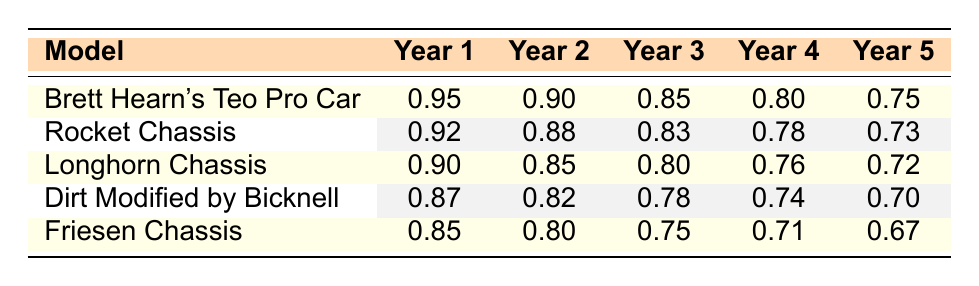What is the survival rate of Brett Hearn's Teo Pro Car after the first year? The survival rate for Brett Hearn's Teo Pro Car after the first year is listed directly in the table under "Year 1." It shows a survival rate of 0.95.
Answer: 0.95 Which car model has the highest survival rate after Year 3? Referring to the values in the "Year 3" column, Brett Hearn's Teo Pro Car has a survival rate of 0.85, Rocket Chassis has 0.83, Longhorn Chassis has 0.80, Dirt Modified by Bicknell has 0.78, and Friesen Chassis has 0.75. The highest among these is Brett Hearn's Teo Pro Car at 0.85.
Answer: Brett Hearn's Teo Pro Car What is the average survival rate for Year 2 across all car models? The "Year 2" survival rates are as follows: 0.90 (Teo Pro Car), 0.88 (Rocket Chassis), 0.85 (Longhorn Chassis), 0.82 (Dirt Modified by Bicknell), and 0.80 (Friesen Chassis). We add these values (0.90 + 0.88 + 0.85 + 0.82 + 0.80 = 4.25) and divide by the number of models, which is 5. Therefore, the average is 4.25 / 5 = 0.85.
Answer: 0.85 Is it true that the Friesen Chassis has a lower survival rate than the Dirt Modified by Bicknell after Year 5? The survival rate for the Friesen Chassis after Year 5 is 0.67, while the Dirt Modified by Bicknell has a survival rate of 0.70. Since 0.67 is less than 0.70, the statement is true.
Answer: Yes What is the difference in survival rates between Year 1 and Year 5 for the Longhorn Chassis? The survival rate for the Longhorn Chassis in Year 1 is 0.90, and in Year 5 it is 0.72. To find the difference, we subtract the Year 5 survival rate from the Year 1 survival rate (0.90 - 0.72 = 0.18).
Answer: 0.18 